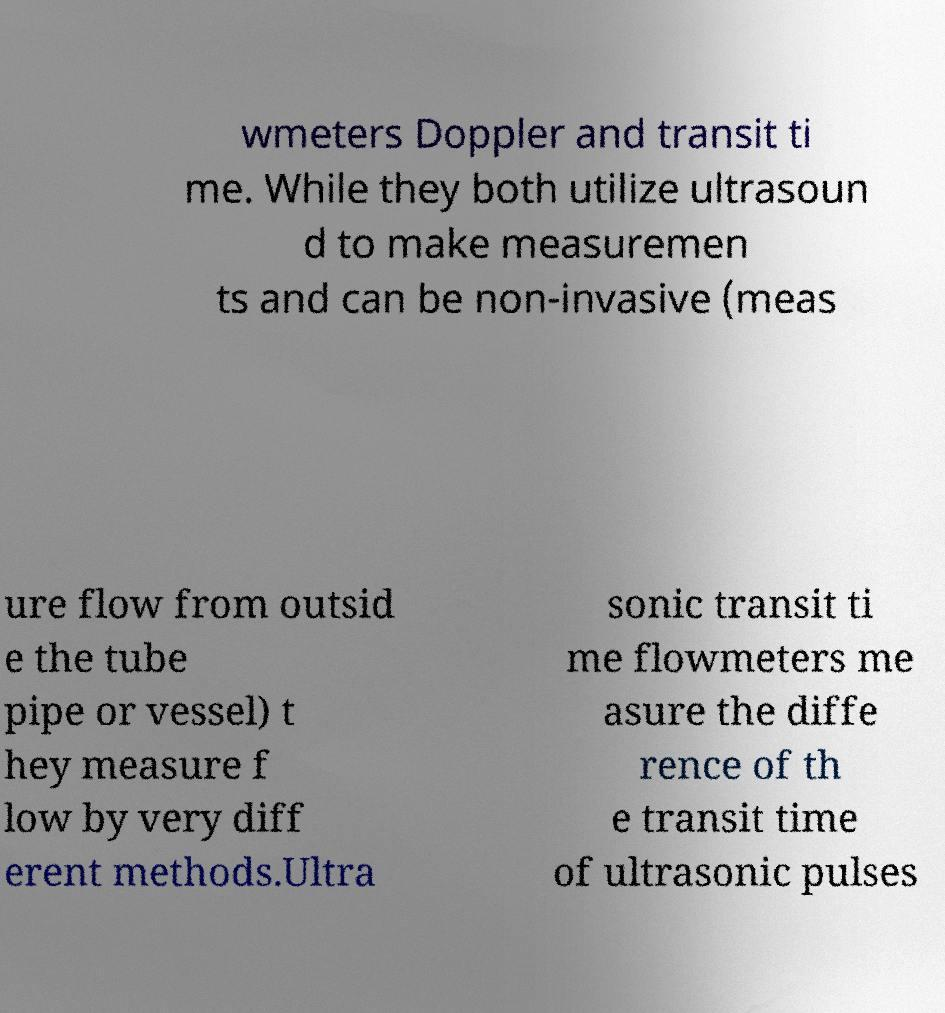Can you accurately transcribe the text from the provided image for me? wmeters Doppler and transit ti me. While they both utilize ultrasoun d to make measuremen ts and can be non-invasive (meas ure flow from outsid e the tube pipe or vessel) t hey measure f low by very diff erent methods.Ultra sonic transit ti me flowmeters me asure the diffe rence of th e transit time of ultrasonic pulses 